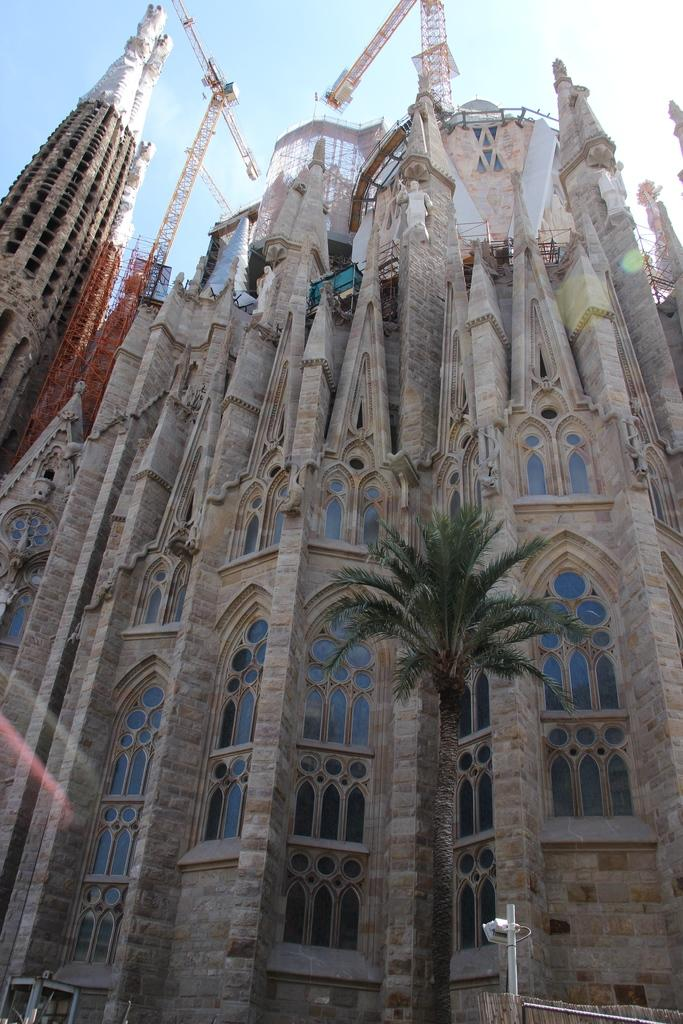What is located in the center of the image? There are buildings in the center of the image. What type of machinery can be seen in the image? There is a crane in the image. What type of vegetation is at the bottom of the image? There is a tree at the bottom of the image. What object is also present at the bottom of the image? There is a pole at the bottom of the image. What is visible at the top of the image? The sky is visible at the top of the image. What type of note is tied to the tree in the image? There is no note tied to the tree in the image. How many knots are visible on the pole in the image? There are no knots visible on the pole in the image. 